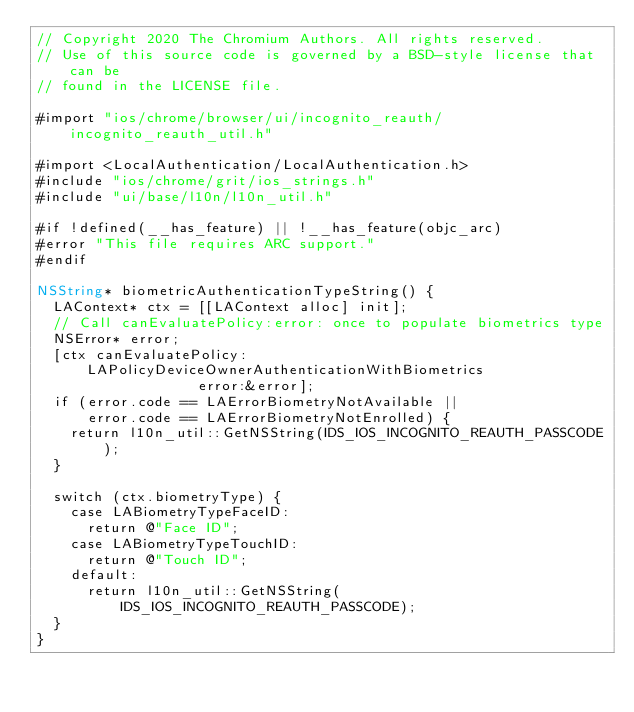<code> <loc_0><loc_0><loc_500><loc_500><_ObjectiveC_>// Copyright 2020 The Chromium Authors. All rights reserved.
// Use of this source code is governed by a BSD-style license that can be
// found in the LICENSE file.

#import "ios/chrome/browser/ui/incognito_reauth/incognito_reauth_util.h"

#import <LocalAuthentication/LocalAuthentication.h>
#include "ios/chrome/grit/ios_strings.h"
#include "ui/base/l10n/l10n_util.h"

#if !defined(__has_feature) || !__has_feature(objc_arc)
#error "This file requires ARC support."
#endif

NSString* biometricAuthenticationTypeString() {
  LAContext* ctx = [[LAContext alloc] init];
  // Call canEvaluatePolicy:error: once to populate biometrics type
  NSError* error;
  [ctx canEvaluatePolicy:LAPolicyDeviceOwnerAuthenticationWithBiometrics
                   error:&error];
  if (error.code == LAErrorBiometryNotAvailable ||
      error.code == LAErrorBiometryNotEnrolled) {
    return l10n_util::GetNSString(IDS_IOS_INCOGNITO_REAUTH_PASSCODE);
  }

  switch (ctx.biometryType) {
    case LABiometryTypeFaceID:
      return @"Face ID";
    case LABiometryTypeTouchID:
      return @"Touch ID";
    default:
      return l10n_util::GetNSString(IDS_IOS_INCOGNITO_REAUTH_PASSCODE);
  }
}
</code> 